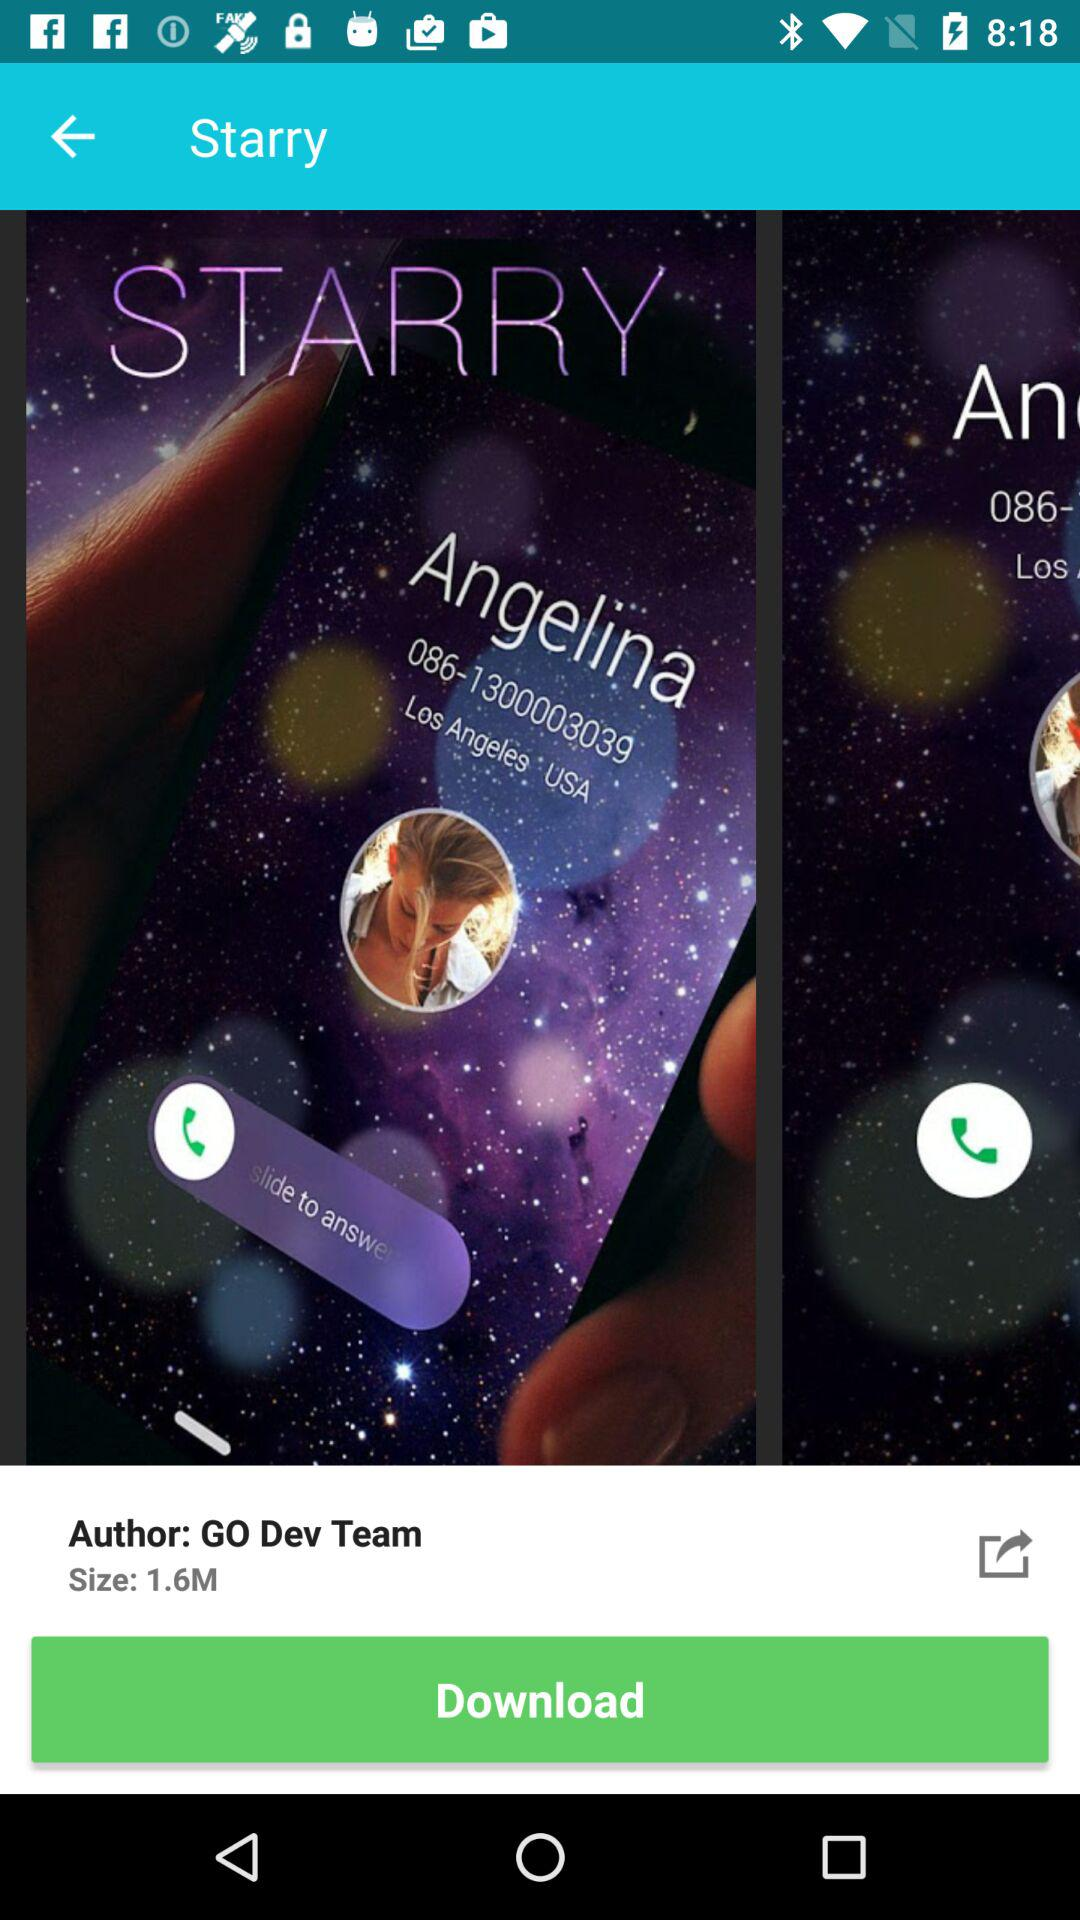Who is the author of "Starry"? The author of "Starry" is "GO Dev Team". 